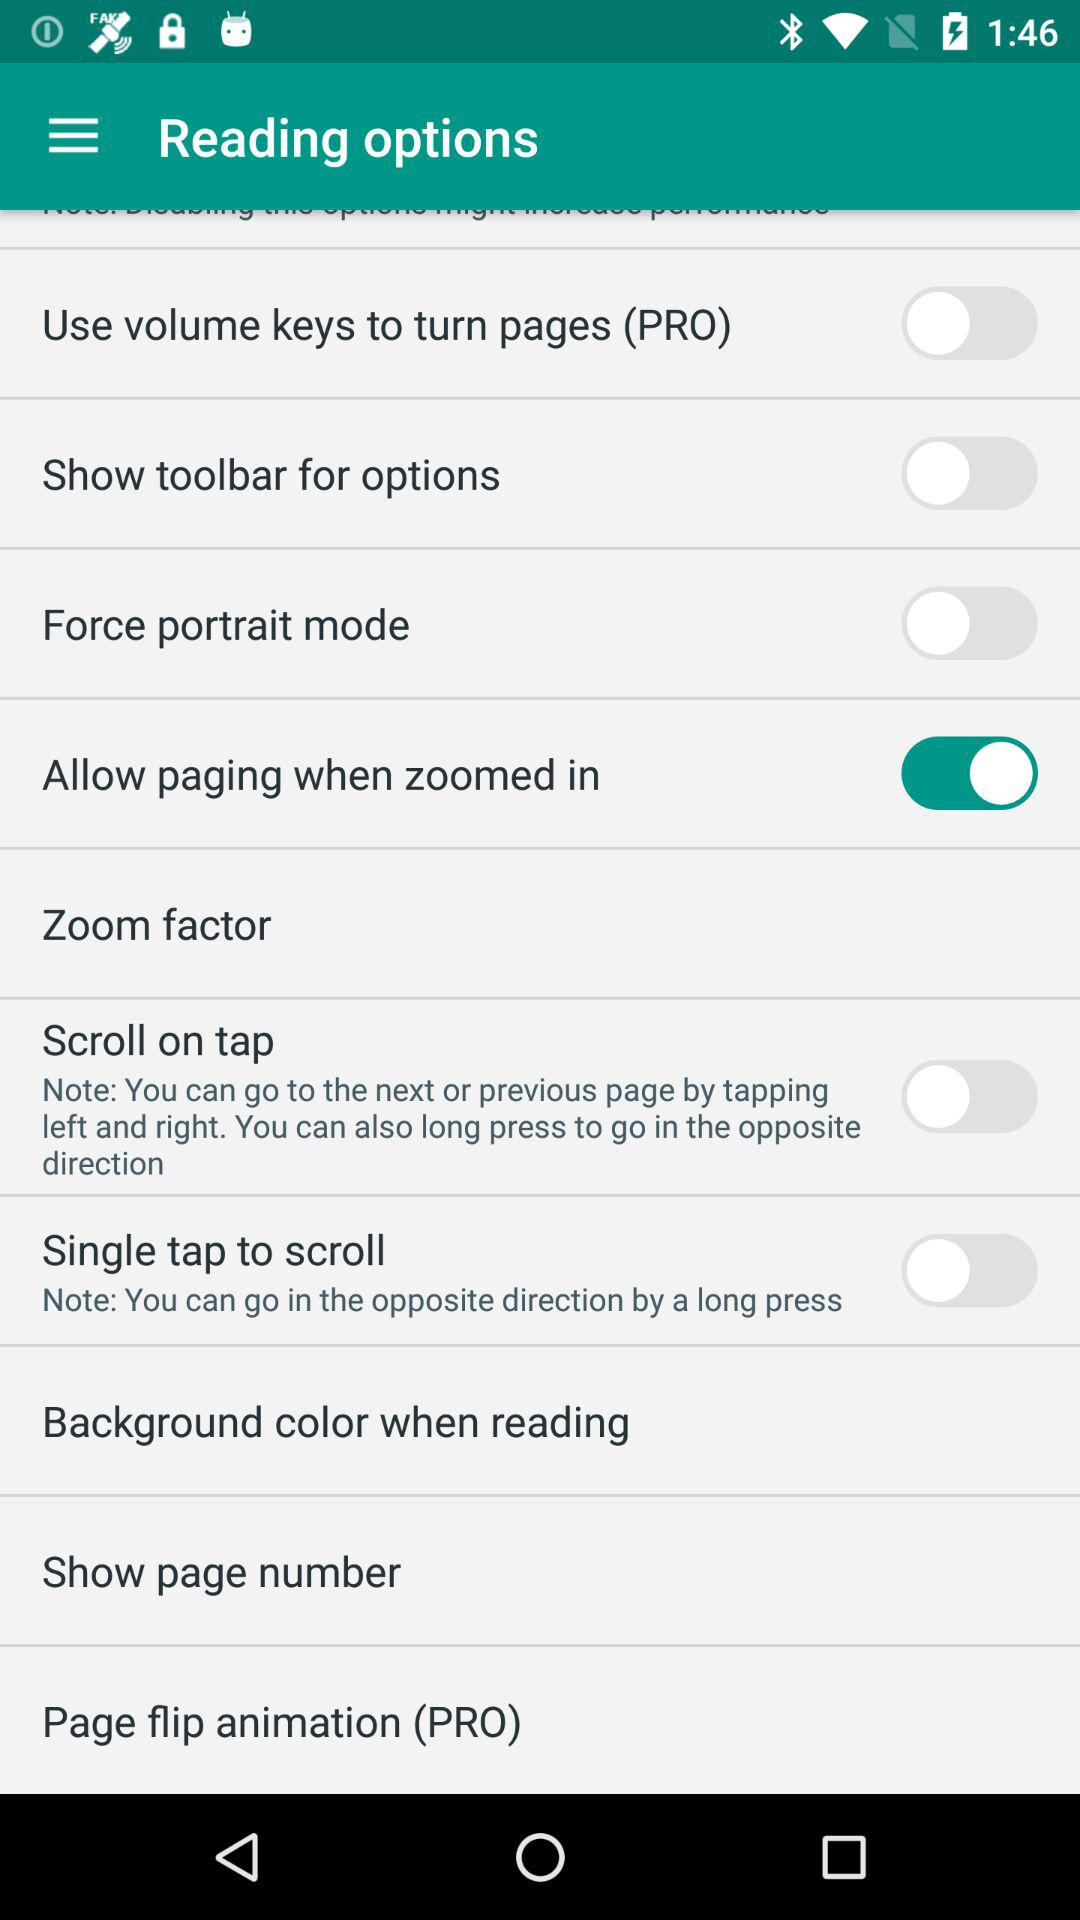What is the status of "Allow paging when zoomed in"? The status is "on". 